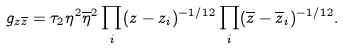<formula> <loc_0><loc_0><loc_500><loc_500>g _ { z \overline { z } } = \tau _ { 2 } \eta ^ { 2 } \overline { \eta } ^ { 2 } \prod _ { i } ( z - z _ { i } ) ^ { - 1 / 1 2 } \prod _ { i } ( \overline { z } - \overline { z } _ { i } ) ^ { - 1 / 1 2 } .</formula> 